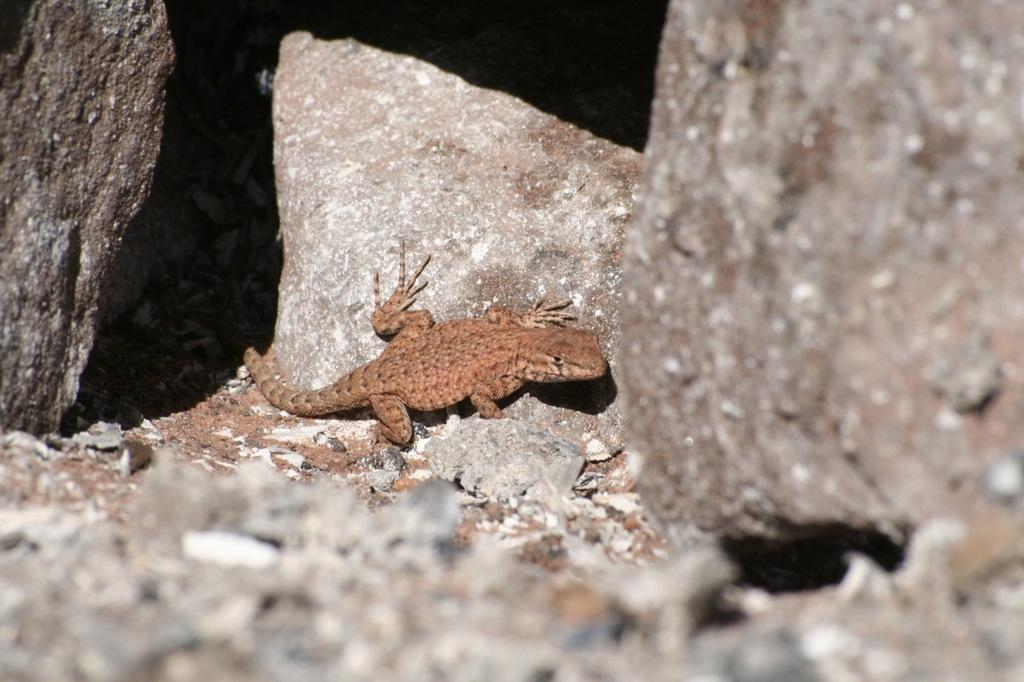What animal is present in the picture? There is a lizard in the picture. What is the lizard resting on? The lizard is on a rock. Are there any other rocks visible in the image? Yes, there are rocks on either side of the lizard. What type of coal is being mined in the background of the image? There is no coal or mining activity present in the image; it features a lizard on a rock with rocks on either side. 